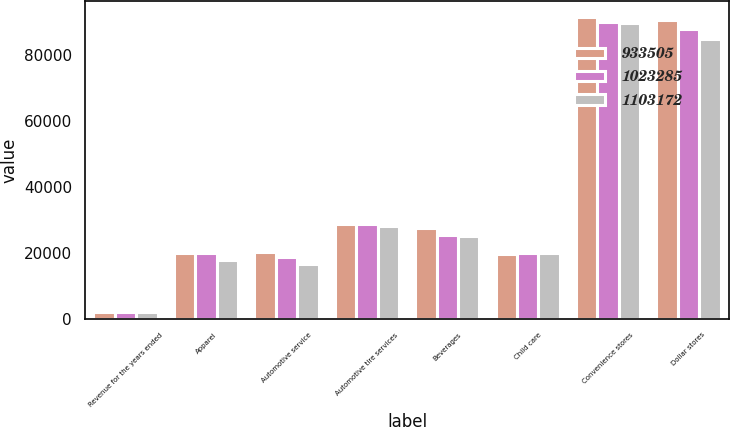<chart> <loc_0><loc_0><loc_500><loc_500><stacked_bar_chart><ecel><fcel>Revenue for the years ended<fcel>Apparel<fcel>Automotive service<fcel>Automotive tire services<fcel>Beverages<fcel>Child care<fcel>Convenience stores<fcel>Dollar stores<nl><fcel>933505<fcel>2016<fcel>19975<fcel>20212<fcel>28754<fcel>27587<fcel>19712<fcel>91784<fcel>90746<nl><fcel>1.02328e+06<fcel>2015<fcel>19819<fcel>18632<fcel>28627<fcel>25451<fcel>19949<fcel>90093<fcel>88126<nl><fcel>1.10317e+06<fcel>2014<fcel>17674<fcel>16548<fcel>28222<fcel>25147<fcel>20022<fcel>89754<fcel>85049<nl></chart> 